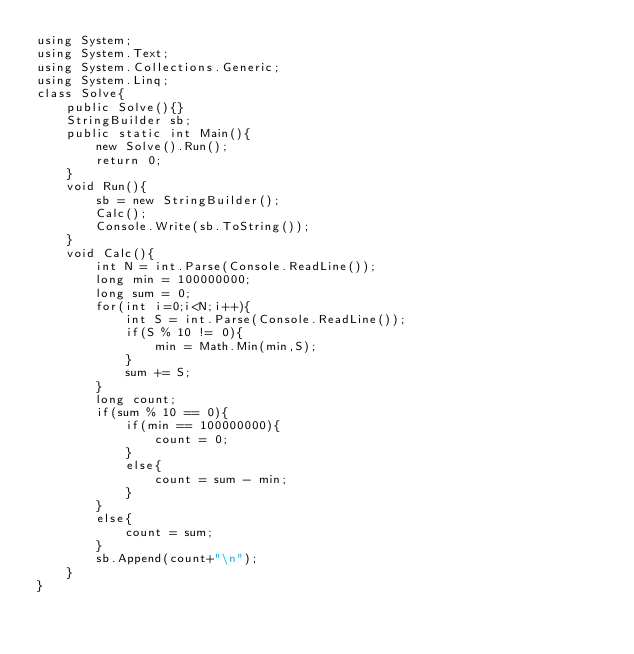Convert code to text. <code><loc_0><loc_0><loc_500><loc_500><_C#_>using System;
using System.Text;
using System.Collections.Generic;
using System.Linq;
class Solve{
    public Solve(){}
    StringBuilder sb;
    public static int Main(){
        new Solve().Run();
        return 0;
    }
    void Run(){
        sb = new StringBuilder();
        Calc();
        Console.Write(sb.ToString());
    }
    void Calc(){
        int N = int.Parse(Console.ReadLine());
        long min = 100000000;
        long sum = 0;
        for(int i=0;i<N;i++){
            int S = int.Parse(Console.ReadLine());
            if(S % 10 != 0){
                min = Math.Min(min,S);
            }
            sum += S;
        }
        long count;
        if(sum % 10 == 0){
            if(min == 100000000){
                count = 0;
            }
            else{
                count = sum - min;
            }
        }
        else{
            count = sum;
        }
        sb.Append(count+"\n");
    }
}</code> 